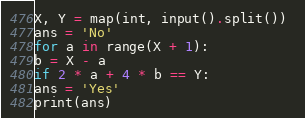<code> <loc_0><loc_0><loc_500><loc_500><_Python_>X, Y = map(int, input().split()) 
ans = 'No' 
for a in range(X + 1):
b = X - a  
if 2 * a + 4 * b == Y: 
ans = 'Yes' 
print(ans)
</code> 